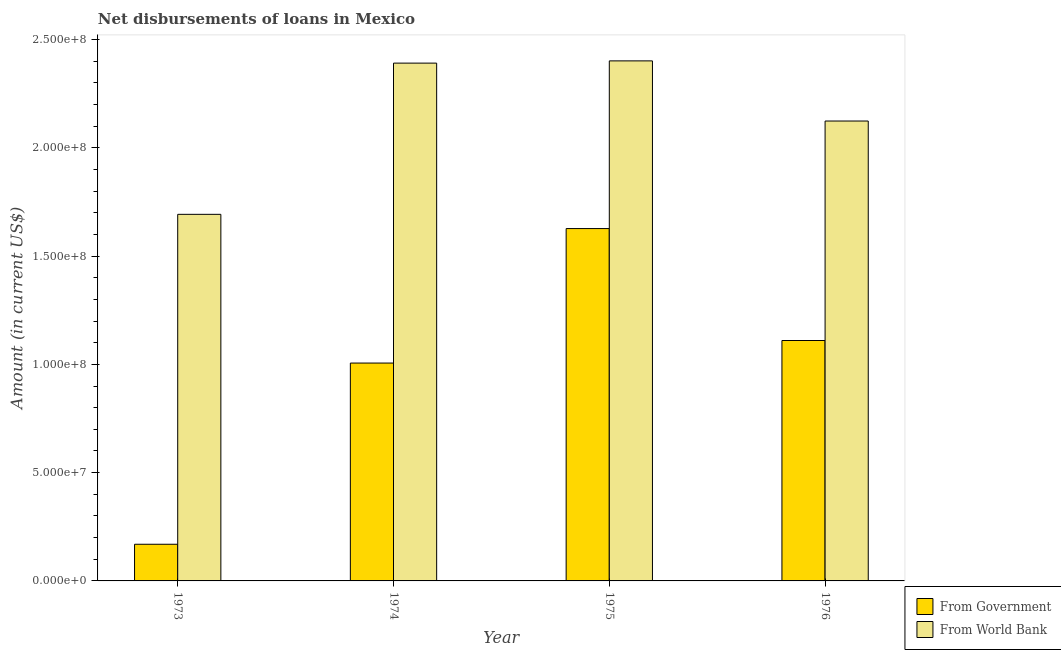How many different coloured bars are there?
Provide a succinct answer. 2. Are the number of bars per tick equal to the number of legend labels?
Give a very brief answer. Yes. Are the number of bars on each tick of the X-axis equal?
Your answer should be very brief. Yes. What is the label of the 2nd group of bars from the left?
Your answer should be very brief. 1974. What is the net disbursements of loan from world bank in 1973?
Ensure brevity in your answer.  1.69e+08. Across all years, what is the maximum net disbursements of loan from government?
Provide a succinct answer. 1.63e+08. Across all years, what is the minimum net disbursements of loan from government?
Offer a terse response. 1.69e+07. In which year was the net disbursements of loan from government maximum?
Offer a terse response. 1975. What is the total net disbursements of loan from world bank in the graph?
Give a very brief answer. 8.61e+08. What is the difference between the net disbursements of loan from government in 1973 and that in 1976?
Your response must be concise. -9.41e+07. What is the difference between the net disbursements of loan from government in 1974 and the net disbursements of loan from world bank in 1976?
Ensure brevity in your answer.  -1.04e+07. What is the average net disbursements of loan from world bank per year?
Offer a very short reply. 2.15e+08. In the year 1974, what is the difference between the net disbursements of loan from world bank and net disbursements of loan from government?
Provide a succinct answer. 0. In how many years, is the net disbursements of loan from world bank greater than 40000000 US$?
Give a very brief answer. 4. What is the ratio of the net disbursements of loan from world bank in 1974 to that in 1976?
Keep it short and to the point. 1.13. Is the net disbursements of loan from world bank in 1973 less than that in 1974?
Keep it short and to the point. Yes. Is the difference between the net disbursements of loan from government in 1973 and 1974 greater than the difference between the net disbursements of loan from world bank in 1973 and 1974?
Offer a very short reply. No. What is the difference between the highest and the second highest net disbursements of loan from government?
Provide a succinct answer. 5.17e+07. What is the difference between the highest and the lowest net disbursements of loan from world bank?
Your answer should be compact. 7.09e+07. In how many years, is the net disbursements of loan from world bank greater than the average net disbursements of loan from world bank taken over all years?
Offer a terse response. 2. What does the 1st bar from the left in 1976 represents?
Make the answer very short. From Government. What does the 2nd bar from the right in 1974 represents?
Your answer should be very brief. From Government. Are all the bars in the graph horizontal?
Your answer should be very brief. No. What is the difference between two consecutive major ticks on the Y-axis?
Offer a terse response. 5.00e+07. Where does the legend appear in the graph?
Provide a succinct answer. Bottom right. How many legend labels are there?
Your answer should be very brief. 2. What is the title of the graph?
Offer a terse response. Net disbursements of loans in Mexico. What is the label or title of the X-axis?
Offer a very short reply. Year. What is the label or title of the Y-axis?
Make the answer very short. Amount (in current US$). What is the Amount (in current US$) in From Government in 1973?
Your response must be concise. 1.69e+07. What is the Amount (in current US$) in From World Bank in 1973?
Keep it short and to the point. 1.69e+08. What is the Amount (in current US$) in From Government in 1974?
Ensure brevity in your answer.  1.01e+08. What is the Amount (in current US$) of From World Bank in 1974?
Your answer should be compact. 2.39e+08. What is the Amount (in current US$) of From Government in 1975?
Your answer should be compact. 1.63e+08. What is the Amount (in current US$) in From World Bank in 1975?
Your answer should be very brief. 2.40e+08. What is the Amount (in current US$) in From Government in 1976?
Keep it short and to the point. 1.11e+08. What is the Amount (in current US$) of From World Bank in 1976?
Your response must be concise. 2.12e+08. Across all years, what is the maximum Amount (in current US$) of From Government?
Provide a succinct answer. 1.63e+08. Across all years, what is the maximum Amount (in current US$) in From World Bank?
Give a very brief answer. 2.40e+08. Across all years, what is the minimum Amount (in current US$) of From Government?
Make the answer very short. 1.69e+07. Across all years, what is the minimum Amount (in current US$) of From World Bank?
Your response must be concise. 1.69e+08. What is the total Amount (in current US$) of From Government in the graph?
Provide a succinct answer. 3.91e+08. What is the total Amount (in current US$) of From World Bank in the graph?
Ensure brevity in your answer.  8.61e+08. What is the difference between the Amount (in current US$) in From Government in 1973 and that in 1974?
Provide a short and direct response. -8.37e+07. What is the difference between the Amount (in current US$) of From World Bank in 1973 and that in 1974?
Give a very brief answer. -6.98e+07. What is the difference between the Amount (in current US$) of From Government in 1973 and that in 1975?
Your response must be concise. -1.46e+08. What is the difference between the Amount (in current US$) of From World Bank in 1973 and that in 1975?
Offer a very short reply. -7.09e+07. What is the difference between the Amount (in current US$) in From Government in 1973 and that in 1976?
Keep it short and to the point. -9.41e+07. What is the difference between the Amount (in current US$) of From World Bank in 1973 and that in 1976?
Provide a succinct answer. -4.31e+07. What is the difference between the Amount (in current US$) in From Government in 1974 and that in 1975?
Give a very brief answer. -6.21e+07. What is the difference between the Amount (in current US$) in From World Bank in 1974 and that in 1975?
Make the answer very short. -1.03e+06. What is the difference between the Amount (in current US$) of From Government in 1974 and that in 1976?
Offer a very short reply. -1.04e+07. What is the difference between the Amount (in current US$) in From World Bank in 1974 and that in 1976?
Keep it short and to the point. 2.67e+07. What is the difference between the Amount (in current US$) in From Government in 1975 and that in 1976?
Your answer should be very brief. 5.17e+07. What is the difference between the Amount (in current US$) of From World Bank in 1975 and that in 1976?
Your answer should be very brief. 2.78e+07. What is the difference between the Amount (in current US$) of From Government in 1973 and the Amount (in current US$) of From World Bank in 1974?
Provide a short and direct response. -2.22e+08. What is the difference between the Amount (in current US$) in From Government in 1973 and the Amount (in current US$) in From World Bank in 1975?
Your answer should be compact. -2.23e+08. What is the difference between the Amount (in current US$) in From Government in 1973 and the Amount (in current US$) in From World Bank in 1976?
Your answer should be compact. -1.95e+08. What is the difference between the Amount (in current US$) of From Government in 1974 and the Amount (in current US$) of From World Bank in 1975?
Provide a short and direct response. -1.40e+08. What is the difference between the Amount (in current US$) of From Government in 1974 and the Amount (in current US$) of From World Bank in 1976?
Give a very brief answer. -1.12e+08. What is the difference between the Amount (in current US$) in From Government in 1975 and the Amount (in current US$) in From World Bank in 1976?
Your answer should be compact. -4.97e+07. What is the average Amount (in current US$) of From Government per year?
Your answer should be compact. 9.78e+07. What is the average Amount (in current US$) in From World Bank per year?
Keep it short and to the point. 2.15e+08. In the year 1973, what is the difference between the Amount (in current US$) in From Government and Amount (in current US$) in From World Bank?
Your answer should be compact. -1.52e+08. In the year 1974, what is the difference between the Amount (in current US$) in From Government and Amount (in current US$) in From World Bank?
Give a very brief answer. -1.39e+08. In the year 1975, what is the difference between the Amount (in current US$) of From Government and Amount (in current US$) of From World Bank?
Your answer should be very brief. -7.74e+07. In the year 1976, what is the difference between the Amount (in current US$) of From Government and Amount (in current US$) of From World Bank?
Offer a very short reply. -1.01e+08. What is the ratio of the Amount (in current US$) of From Government in 1973 to that in 1974?
Provide a short and direct response. 0.17. What is the ratio of the Amount (in current US$) of From World Bank in 1973 to that in 1974?
Your answer should be very brief. 0.71. What is the ratio of the Amount (in current US$) in From Government in 1973 to that in 1975?
Keep it short and to the point. 0.1. What is the ratio of the Amount (in current US$) of From World Bank in 1973 to that in 1975?
Make the answer very short. 0.7. What is the ratio of the Amount (in current US$) of From Government in 1973 to that in 1976?
Your answer should be compact. 0.15. What is the ratio of the Amount (in current US$) of From World Bank in 1973 to that in 1976?
Your answer should be very brief. 0.8. What is the ratio of the Amount (in current US$) in From Government in 1974 to that in 1975?
Your answer should be very brief. 0.62. What is the ratio of the Amount (in current US$) in From Government in 1974 to that in 1976?
Your answer should be compact. 0.91. What is the ratio of the Amount (in current US$) in From World Bank in 1974 to that in 1976?
Provide a short and direct response. 1.13. What is the ratio of the Amount (in current US$) in From Government in 1975 to that in 1976?
Make the answer very short. 1.47. What is the ratio of the Amount (in current US$) of From World Bank in 1975 to that in 1976?
Ensure brevity in your answer.  1.13. What is the difference between the highest and the second highest Amount (in current US$) in From Government?
Your response must be concise. 5.17e+07. What is the difference between the highest and the second highest Amount (in current US$) of From World Bank?
Make the answer very short. 1.03e+06. What is the difference between the highest and the lowest Amount (in current US$) in From Government?
Ensure brevity in your answer.  1.46e+08. What is the difference between the highest and the lowest Amount (in current US$) of From World Bank?
Make the answer very short. 7.09e+07. 